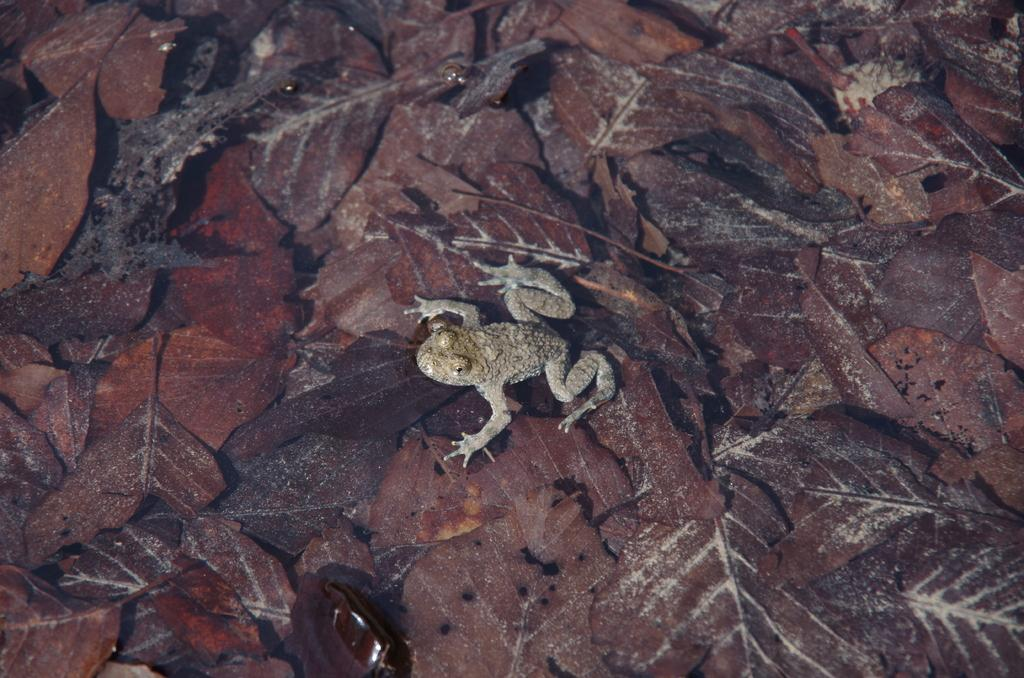What animal is present in the image? There is a frog in the image. Where is the frog located? The frog is on leaves. What type of jar is the frog sitting in the image? There is no jar present in the image; the frog is on leaves. What beverage is the frog drinking in the image? There is no beverage present in the image, as the frog is on leaves. 